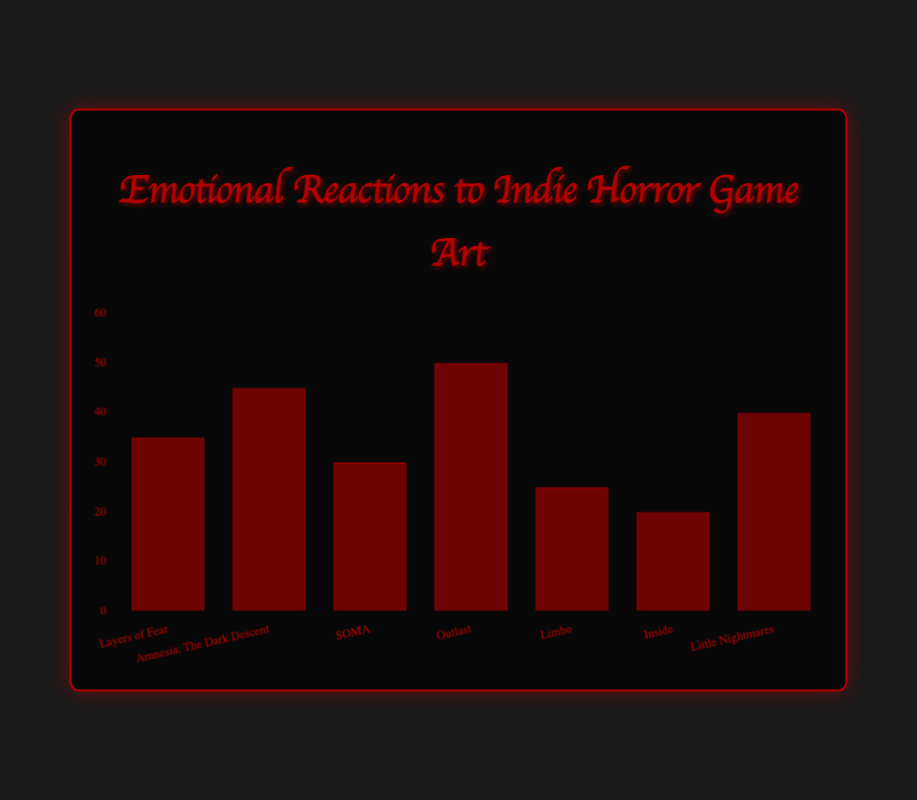What's the highest percentage of emotional reaction among the games and which emoji represents it? The highest percentage is noted for "Outlast" with a 50% reaction rate. The figure shows the emoji 😱 for this game.
Answer: 😱, 50% Which game received the lowest percentage of emotional reaction and what emoji represents it? "Inside" has the lowest percentage of emotional reaction at 20%, represented by the emoji 😳.
Answer: 😳, 20% How many games have a reaction percentage greater than 30%? The games with reaction percentages greater than 30% are "Layers of Fear" (35%), "Amnesia: The Dark Descent" (45%), "Outlast" (50%), and "Little Nightmares" (40%). There are 4 such games.
Answer: 4 What is the average reaction percentage across all the games? Sum the reaction percentages (35 + 45 + 30 + 50 + 25 + 20 + 40) = 245. There are 7 games, so the average is 245 / 7 = 35%.
Answer: 35% Which two games have the same emotional reaction emoji and what are their percentages? "Layers of Fear" and "Little Nightmares" both have the emoji 😨. Their percentages are 35% and 40% respectively.
Answer: 😨, 35%, 40% What is the difference in reaction percentage between "Amnesia: The Dark Descent" and "SOMA"? "Amnesia: The Dark Descent" has a 45% reaction and "SOMA" has a 30% reaction. The difference is 45% - 30% = 15%.
Answer: 15% Compare the emotional reaction percentages of "Outlast" and "Limbo". Which is higher, and by how much? "Outlast" has a 50% reaction while "Limbo" has a 25% reaction. "Outlast" is higher by 50% - 25% = 25%.
Answer: "Outlast", 25% What emoji is associated with the game that has a 25% reaction rate? The game with a 25% reaction rate is "Limbo," and the associated emoji is 😧.
Answer: 😧 Which game has a 45% emotional reaction and what emoji represents it? "Amnesia: The Dark Descent" has a 45% emotional reaction, represented by the emoji 😱.
Answer: 😱 If the reactions for "Inside" and "Little Nightmares" were summed, what would be the new percentage? The reaction percentages are 20% for "Inside" and 40% for "Little Nightmares." Summing them gives 20% + 40% = 60%.
Answer: 60% 